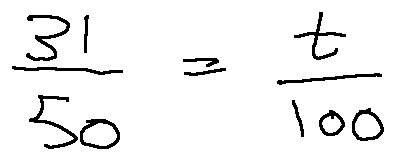<formula> <loc_0><loc_0><loc_500><loc_500>\frac { 3 1 } { 5 0 } = \frac { t } { 1 0 0 }</formula> 